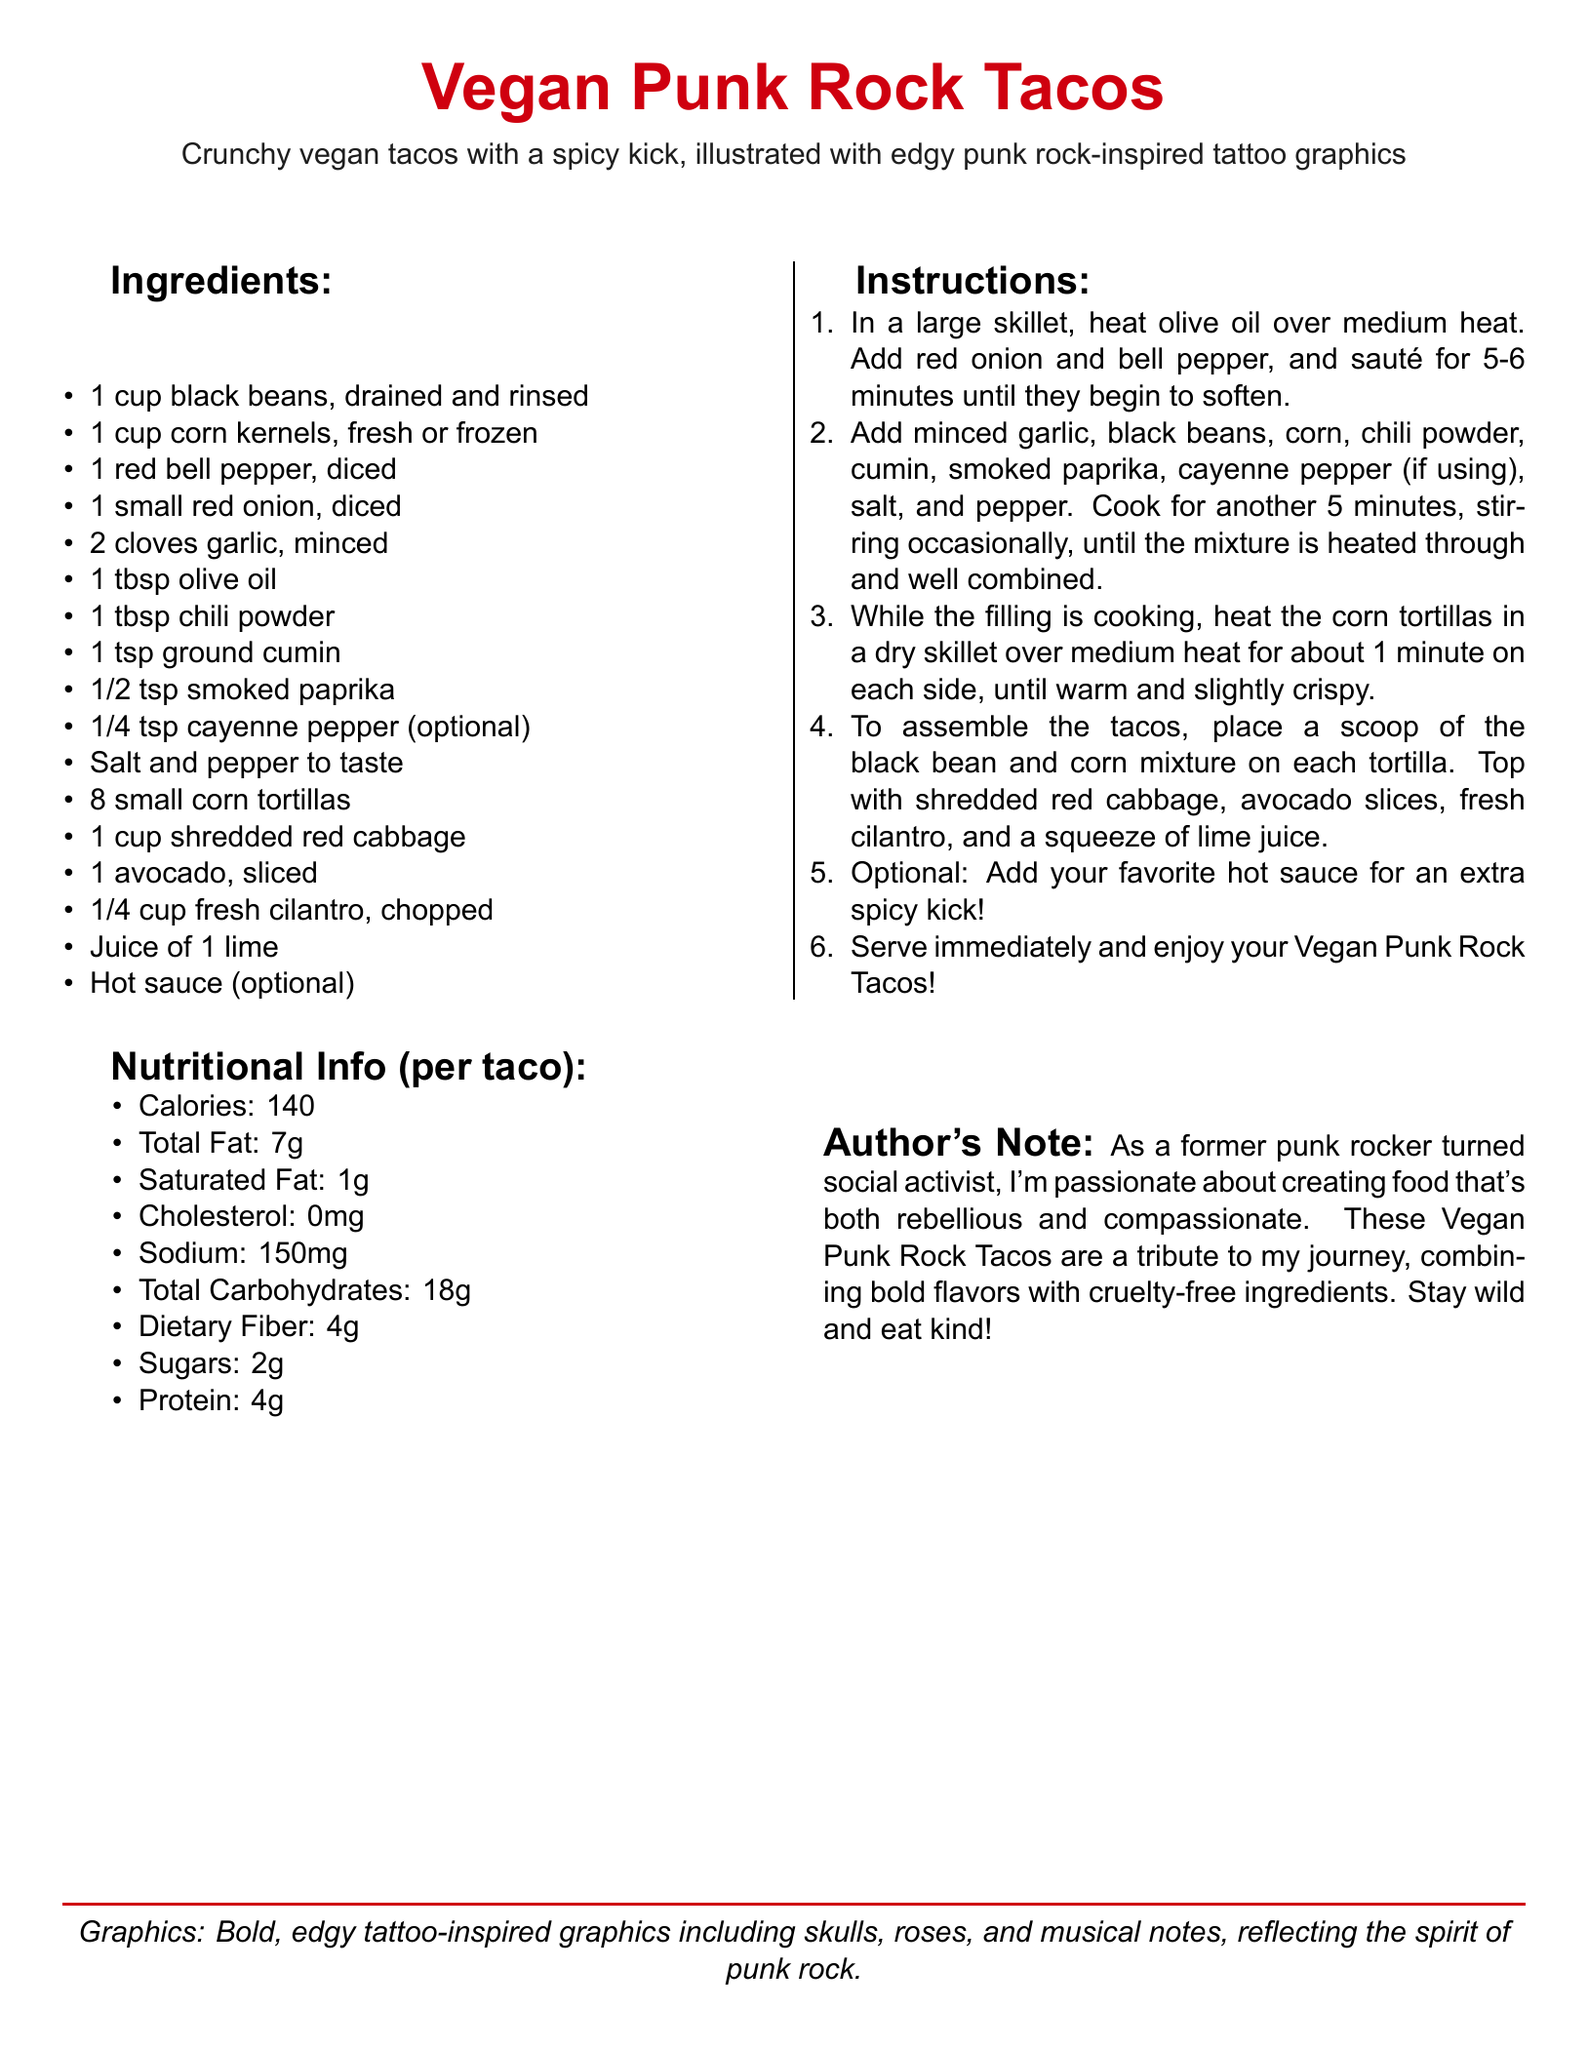What are the main ingredients? The main ingredients are listed in the ingredients section, highlighting the essential components for the tacos.
Answer: black beans, corn, red bell pepper, red onion, garlic, olive oil, chili powder, ground cumin, smoked paprika, cayenne pepper, salt, pepper, corn tortillas, red cabbage, avocado, cilantro, lime, hot sauce How many tacos does the recipe serve? The recipe does not explicitly state the number of servings, but the number of tortillas suggests a serving size.
Answer: 8 tacos What is the calorie count per taco? The nutritional information section specifies the calories per taco.
Answer: 140 What type of oil is used in the recipe? The ingredients list mentions the type of oil required for cooking the filling.
Answer: olive oil What is the optional ingredient for spice? The ingredients list includes an optional ingredient that adds spiciness; this highlights customization based on preference.
Answer: cayenne pepper What cooking method is used for the tortillas? The instructions detail the technique used to prepare the tortillas before serving.
Answer: heated in a dry skillet What might the author's tone suggest about the recipe? The author's note indicates the emotional connection between the recipe and their personal journey, influencing the recipe's spirit.
Answer: rebellious and compassionate Which graphic elements are included in the recipe's design? The document describes the visual style accompanied with the recipe, enhancing its punk rock theme.
Answer: skulls, roses, musical notes 